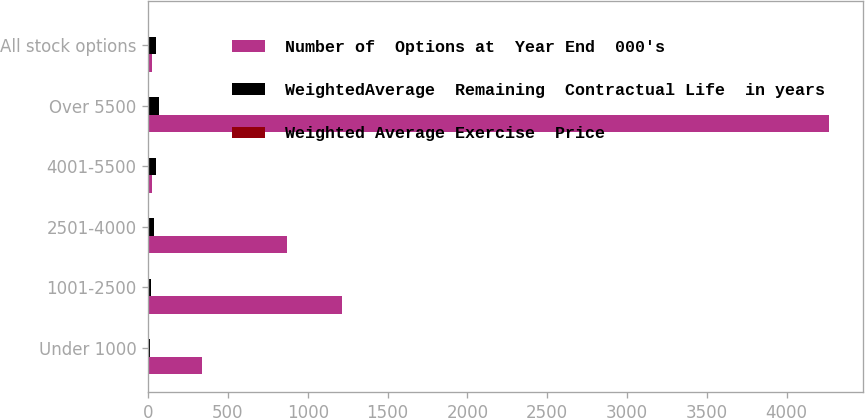<chart> <loc_0><loc_0><loc_500><loc_500><stacked_bar_chart><ecel><fcel>Under 1000<fcel>1001-2500<fcel>2501-4000<fcel>4001-5500<fcel>Over 5500<fcel>All stock options<nl><fcel>Number of  Options at  Year End  000's<fcel>335<fcel>1212<fcel>871<fcel>24.82<fcel>4267<fcel>24.82<nl><fcel>WeightedAverage  Remaining  Contractual Life  in years<fcel>9.3<fcel>15.27<fcel>34.37<fcel>48.36<fcel>66.61<fcel>48.97<nl><fcel>Weighted Average Exercise  Price<fcel>2.34<fcel>3.91<fcel>2<fcel>1.99<fcel>3.26<fcel>2.37<nl></chart> 